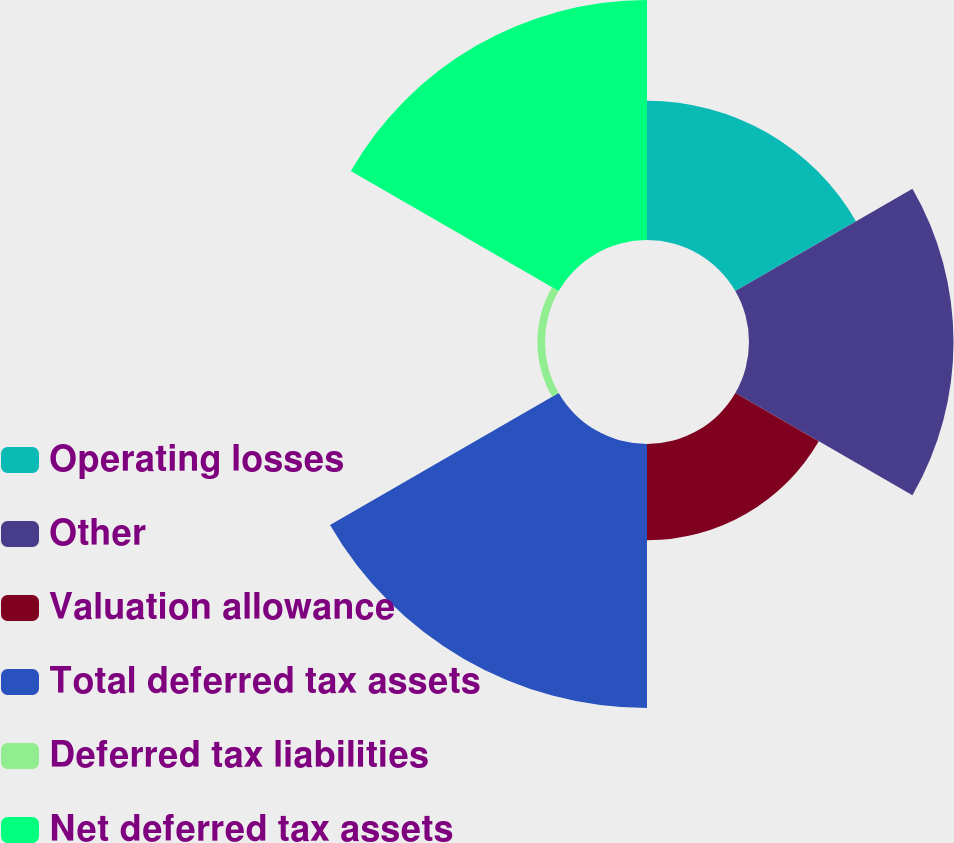<chart> <loc_0><loc_0><loc_500><loc_500><pie_chart><fcel>Operating losses<fcel>Other<fcel>Valuation allowance<fcel>Total deferred tax assets<fcel>Deferred tax liabilities<fcel>Net deferred tax assets<nl><fcel>14.64%<fcel>21.49%<fcel>10.12%<fcel>27.74%<fcel>0.8%<fcel>25.22%<nl></chart> 